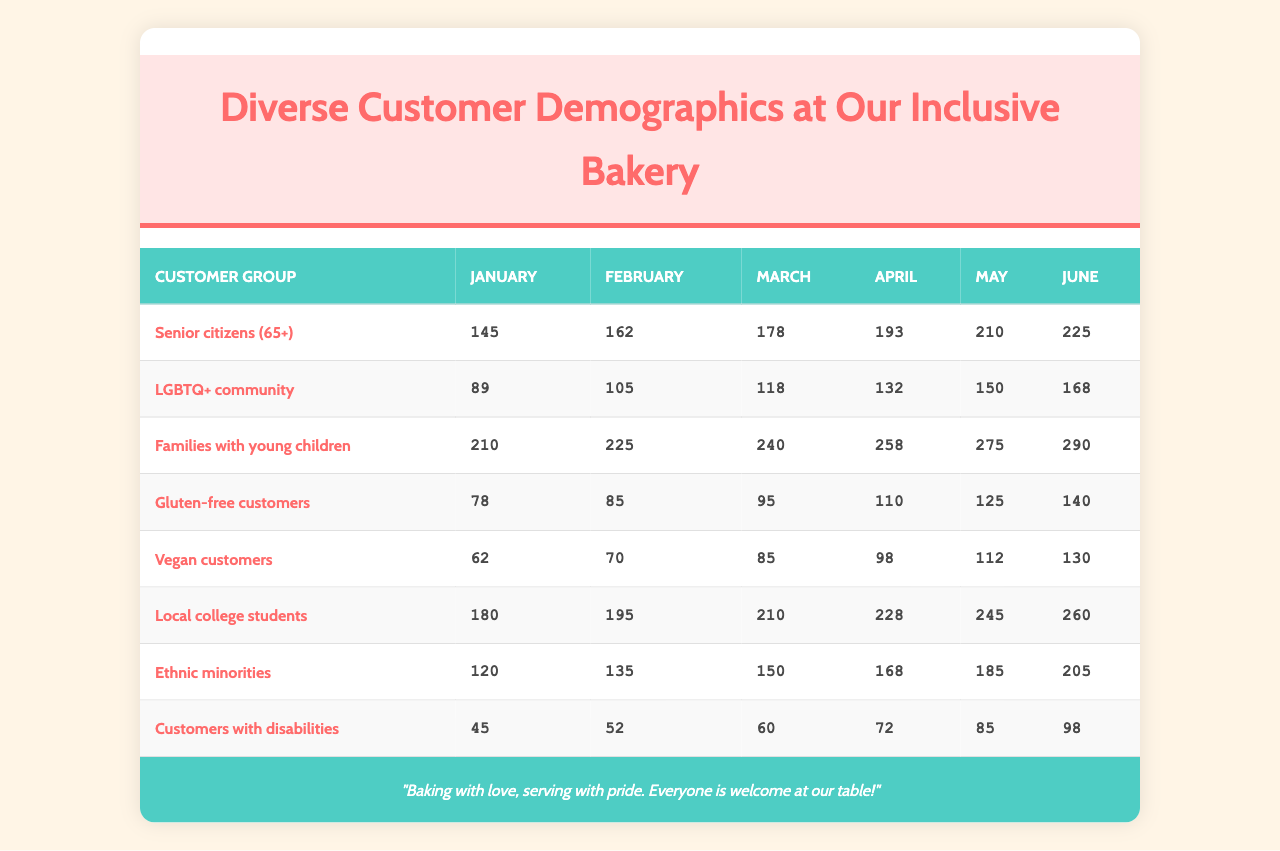What was the total number of visits from families with young children in May? To find the total visits in May for families with young children, we look at the visits column for May, which is 275.
Answer: 275 Which customer group had the least number of visits in June? In June, we can compare visits: Senior citizens (225), LGBTQ+ community (168), Families with young children (290), Gluten-free customers (140), Vegan customers (130), Local college students (260), Ethnic minorities (205), Customers with disabilities (98). The least is Customers with disabilities (98).
Answer: Customers with disabilities What is the difference in visits between senior citizens and local college students in March? In March, senior citizens had 178 visits, while local college students had 210 visits. The difference is 210 - 178 = 32.
Answer: 32 What was the average number of visits for gluten-free customers over the six months? To calculate the average, we sum the visits (78 + 85 + 95 + 110 + 125 + 140 = 733) and divide by 6, which gives 733 / 6 = 122.17. Hence, the average visits is approximately 122.
Answer: 122 Did visits from the LGBTQ+ community increase every month from January to June? Looking at the data: January (89), February (105), March (118), April (132), May (150), June (168). Each month's visits are greater than the previous month. Therefore, yes, they increased every month.
Answer: Yes What is the total number of visits by ethnic minorities for the six months combined? We sum the visits: 120 + 135 + 150 + 168 + 185 + 205 = 1063.
Answer: 1063 Which two groups had the highest total visits combined in April? For April, senior citizens had 193 visits and families with young children had 258 visits. The combined total is 193 + 258 = 451.
Answer: 451 How many more visits did local college students receive than gluten-free customers in January? In January, local college students had 180 visits and gluten-free customers had 78 visits. The difference is 180 - 78 = 102.
Answer: 102 Which group had the highest number of visits in the month of May? In May, we compare the visits: Senior citizens (210), LGBTQ+ community (150), Families with young children (275), Gluten-free customers (125), Vegan customers (112), Local college students (245), Ethnic minorities (185), Customers with disabilities (85). Families with young children had the most.
Answer: Families with young children What is the total increase in visits from vegan customers from January to June? In January, vegan customers had 62 visits and in June, they had 130 visits. The increase is 130 - 62 = 68.
Answer: 68 